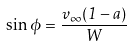Convert formula to latex. <formula><loc_0><loc_0><loc_500><loc_500>\sin \phi = \frac { v _ { \infty } ( 1 - a ) } { W }</formula> 